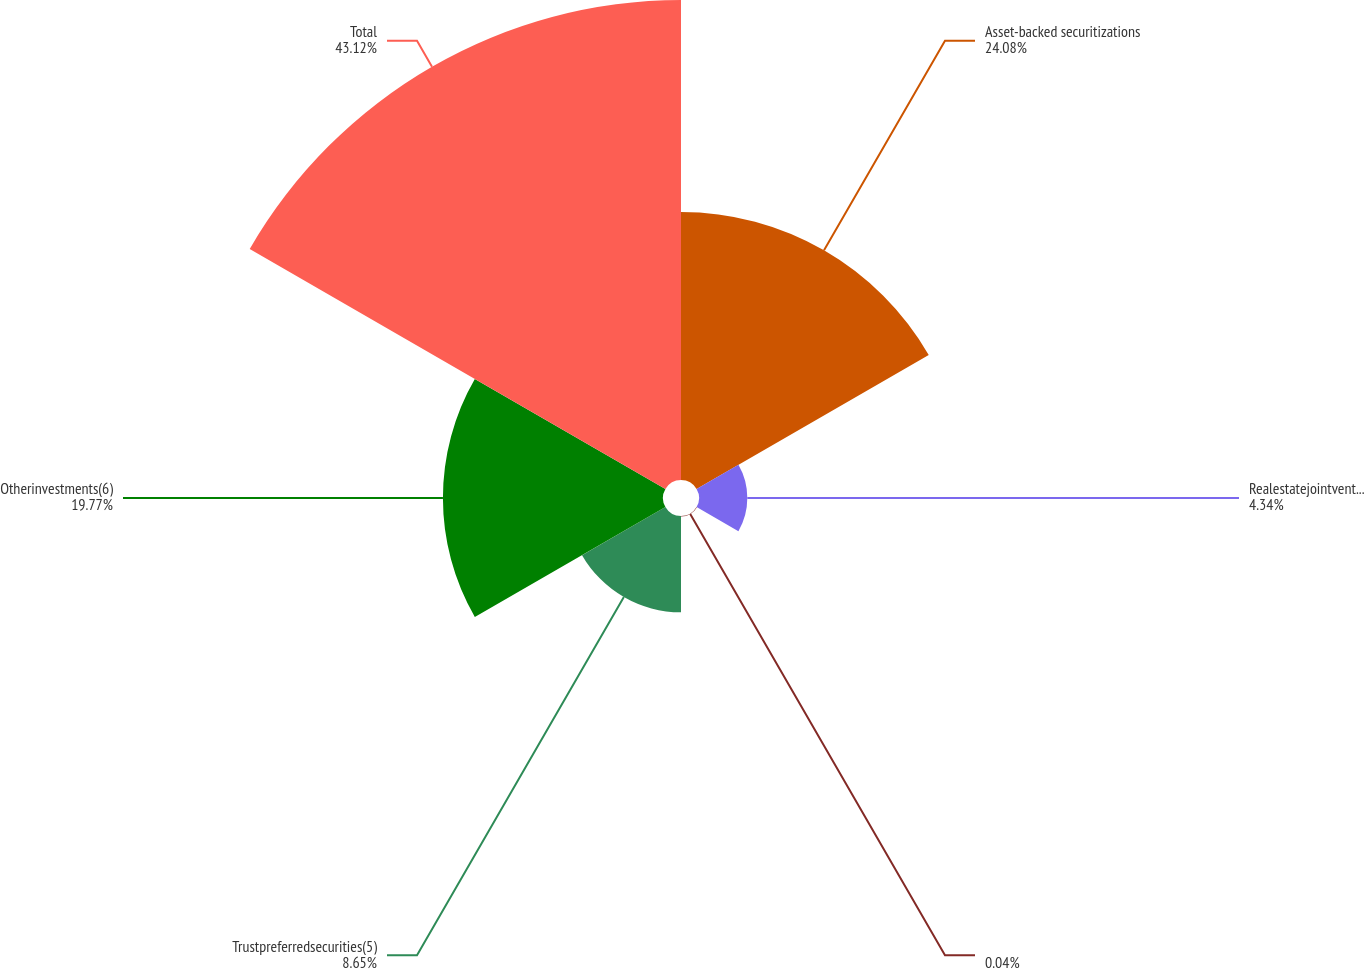Convert chart. <chart><loc_0><loc_0><loc_500><loc_500><pie_chart><fcel>Asset-backed securitizations<fcel>Realestatejointventures(3)<fcel>Unnamed: 2<fcel>Trustpreferredsecurities(5)<fcel>Otherinvestments(6)<fcel>Total<nl><fcel>24.08%<fcel>4.34%<fcel>0.04%<fcel>8.65%<fcel>19.77%<fcel>43.12%<nl></chart> 